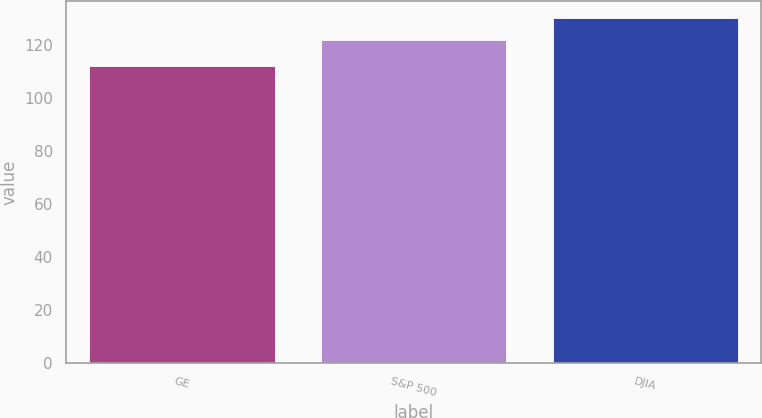Convert chart to OTSL. <chart><loc_0><loc_0><loc_500><loc_500><bar_chart><fcel>GE<fcel>S&P 500<fcel>DJIA<nl><fcel>112<fcel>122<fcel>130<nl></chart> 